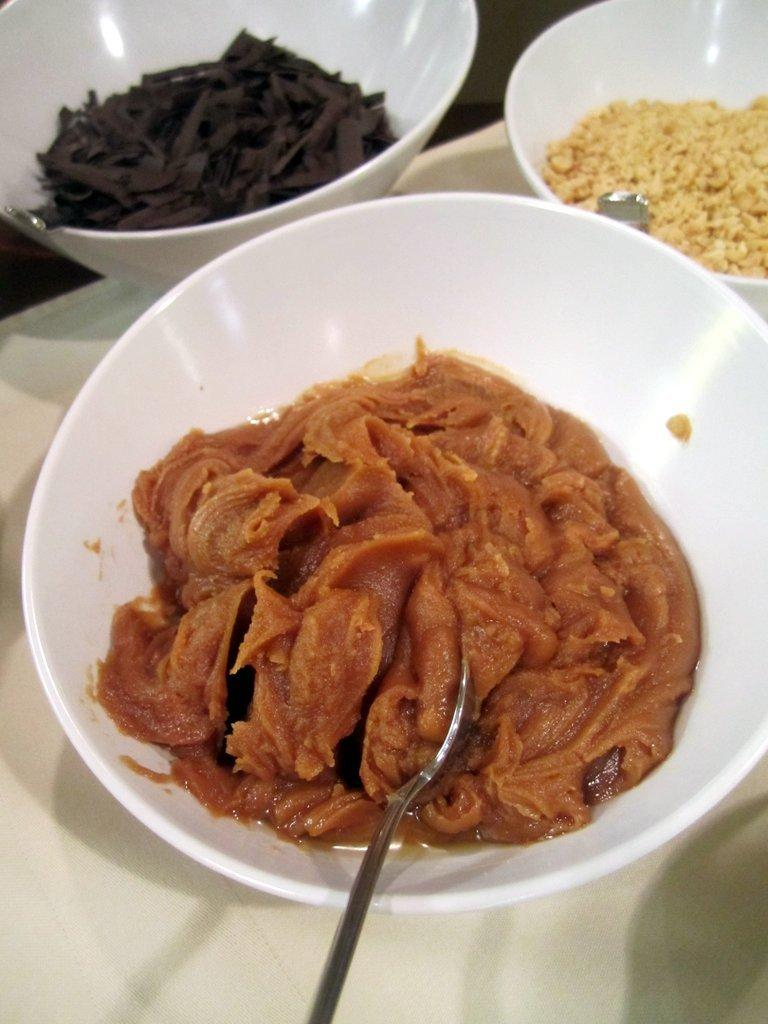What type of objects can be seen in the image? There are food items in the image. How are the food items presented? The food items are in white color bowls. What utensil is visible in the image? There is a spoon visible in the image. What is the color of the surface on which the food items and spoon are placed? The food items and spoon are on a white surface. Where is the meeting taking place in the image? There is no meeting taking place in the image; it only shows food items in bowls, a spoon, and a white surface. 